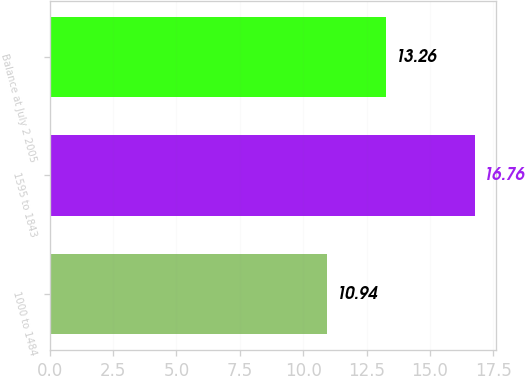Convert chart. <chart><loc_0><loc_0><loc_500><loc_500><bar_chart><fcel>1000 to 1484<fcel>1595 to 1843<fcel>Balance at July 2 2005<nl><fcel>10.94<fcel>16.76<fcel>13.26<nl></chart> 